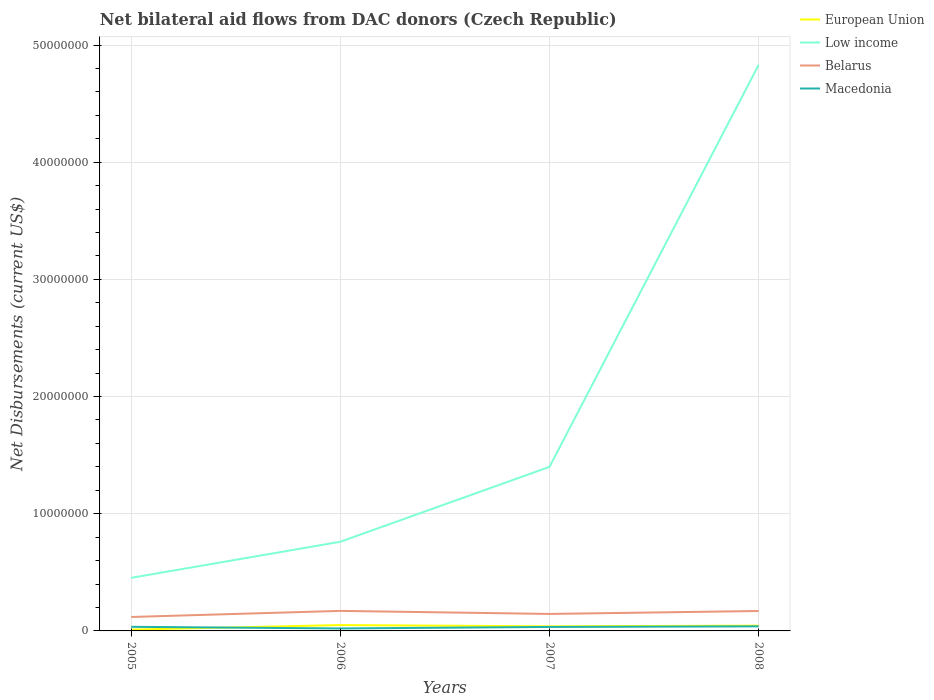Does the line corresponding to Macedonia intersect with the line corresponding to Belarus?
Offer a very short reply. No. What is the total net bilateral aid flows in European Union in the graph?
Offer a very short reply. -2.80e+05. What is the difference between the highest and the second highest net bilateral aid flows in Macedonia?
Provide a short and direct response. 1.80e+05. How many years are there in the graph?
Keep it short and to the point. 4. Does the graph contain grids?
Offer a very short reply. Yes. How many legend labels are there?
Offer a terse response. 4. How are the legend labels stacked?
Give a very brief answer. Vertical. What is the title of the graph?
Provide a short and direct response. Net bilateral aid flows from DAC donors (Czech Republic). Does "Sudan" appear as one of the legend labels in the graph?
Provide a short and direct response. No. What is the label or title of the X-axis?
Offer a very short reply. Years. What is the label or title of the Y-axis?
Offer a terse response. Net Disbursements (current US$). What is the Net Disbursements (current US$) in Low income in 2005?
Give a very brief answer. 4.53e+06. What is the Net Disbursements (current US$) in Belarus in 2005?
Your answer should be very brief. 1.19e+06. What is the Net Disbursements (current US$) in Macedonia in 2005?
Your response must be concise. 3.50e+05. What is the Net Disbursements (current US$) in European Union in 2006?
Your answer should be compact. 5.00e+05. What is the Net Disbursements (current US$) of Low income in 2006?
Offer a terse response. 7.61e+06. What is the Net Disbursements (current US$) in Belarus in 2006?
Your answer should be very brief. 1.71e+06. What is the Net Disbursements (current US$) of Macedonia in 2006?
Give a very brief answer. 2.10e+05. What is the Net Disbursements (current US$) of European Union in 2007?
Make the answer very short. 3.90e+05. What is the Net Disbursements (current US$) in Low income in 2007?
Give a very brief answer. 1.40e+07. What is the Net Disbursements (current US$) in Belarus in 2007?
Make the answer very short. 1.45e+06. What is the Net Disbursements (current US$) in Low income in 2008?
Give a very brief answer. 4.83e+07. What is the Net Disbursements (current US$) in Belarus in 2008?
Your answer should be very brief. 1.70e+06. What is the Net Disbursements (current US$) of Macedonia in 2008?
Keep it short and to the point. 3.90e+05. Across all years, what is the maximum Net Disbursements (current US$) in Low income?
Your response must be concise. 4.83e+07. Across all years, what is the maximum Net Disbursements (current US$) in Belarus?
Provide a short and direct response. 1.71e+06. Across all years, what is the maximum Net Disbursements (current US$) of Macedonia?
Keep it short and to the point. 3.90e+05. Across all years, what is the minimum Net Disbursements (current US$) in Low income?
Offer a very short reply. 4.53e+06. Across all years, what is the minimum Net Disbursements (current US$) of Belarus?
Provide a succinct answer. 1.19e+06. Across all years, what is the minimum Net Disbursements (current US$) of Macedonia?
Your answer should be compact. 2.10e+05. What is the total Net Disbursements (current US$) of European Union in the graph?
Ensure brevity in your answer.  1.45e+06. What is the total Net Disbursements (current US$) in Low income in the graph?
Your answer should be very brief. 7.44e+07. What is the total Net Disbursements (current US$) in Belarus in the graph?
Provide a short and direct response. 6.05e+06. What is the total Net Disbursements (current US$) in Macedonia in the graph?
Your answer should be very brief. 1.29e+06. What is the difference between the Net Disbursements (current US$) of European Union in 2005 and that in 2006?
Your answer should be very brief. -3.90e+05. What is the difference between the Net Disbursements (current US$) of Low income in 2005 and that in 2006?
Keep it short and to the point. -3.08e+06. What is the difference between the Net Disbursements (current US$) of Belarus in 2005 and that in 2006?
Provide a succinct answer. -5.20e+05. What is the difference between the Net Disbursements (current US$) in European Union in 2005 and that in 2007?
Your answer should be very brief. -2.80e+05. What is the difference between the Net Disbursements (current US$) of Low income in 2005 and that in 2007?
Offer a terse response. -9.47e+06. What is the difference between the Net Disbursements (current US$) of Belarus in 2005 and that in 2007?
Make the answer very short. -2.60e+05. What is the difference between the Net Disbursements (current US$) of European Union in 2005 and that in 2008?
Make the answer very short. -3.40e+05. What is the difference between the Net Disbursements (current US$) in Low income in 2005 and that in 2008?
Ensure brevity in your answer.  -4.38e+07. What is the difference between the Net Disbursements (current US$) in Belarus in 2005 and that in 2008?
Your answer should be compact. -5.10e+05. What is the difference between the Net Disbursements (current US$) of Macedonia in 2005 and that in 2008?
Offer a very short reply. -4.00e+04. What is the difference between the Net Disbursements (current US$) in European Union in 2006 and that in 2007?
Give a very brief answer. 1.10e+05. What is the difference between the Net Disbursements (current US$) in Low income in 2006 and that in 2007?
Your response must be concise. -6.39e+06. What is the difference between the Net Disbursements (current US$) of European Union in 2006 and that in 2008?
Keep it short and to the point. 5.00e+04. What is the difference between the Net Disbursements (current US$) in Low income in 2006 and that in 2008?
Your answer should be very brief. -4.07e+07. What is the difference between the Net Disbursements (current US$) in European Union in 2007 and that in 2008?
Provide a short and direct response. -6.00e+04. What is the difference between the Net Disbursements (current US$) in Low income in 2007 and that in 2008?
Offer a terse response. -3.43e+07. What is the difference between the Net Disbursements (current US$) in Belarus in 2007 and that in 2008?
Give a very brief answer. -2.50e+05. What is the difference between the Net Disbursements (current US$) of Macedonia in 2007 and that in 2008?
Offer a very short reply. -5.00e+04. What is the difference between the Net Disbursements (current US$) of European Union in 2005 and the Net Disbursements (current US$) of Low income in 2006?
Keep it short and to the point. -7.50e+06. What is the difference between the Net Disbursements (current US$) in European Union in 2005 and the Net Disbursements (current US$) in Belarus in 2006?
Your answer should be very brief. -1.60e+06. What is the difference between the Net Disbursements (current US$) in Low income in 2005 and the Net Disbursements (current US$) in Belarus in 2006?
Offer a terse response. 2.82e+06. What is the difference between the Net Disbursements (current US$) in Low income in 2005 and the Net Disbursements (current US$) in Macedonia in 2006?
Keep it short and to the point. 4.32e+06. What is the difference between the Net Disbursements (current US$) in Belarus in 2005 and the Net Disbursements (current US$) in Macedonia in 2006?
Ensure brevity in your answer.  9.80e+05. What is the difference between the Net Disbursements (current US$) of European Union in 2005 and the Net Disbursements (current US$) of Low income in 2007?
Give a very brief answer. -1.39e+07. What is the difference between the Net Disbursements (current US$) in European Union in 2005 and the Net Disbursements (current US$) in Belarus in 2007?
Keep it short and to the point. -1.34e+06. What is the difference between the Net Disbursements (current US$) of Low income in 2005 and the Net Disbursements (current US$) of Belarus in 2007?
Your answer should be compact. 3.08e+06. What is the difference between the Net Disbursements (current US$) in Low income in 2005 and the Net Disbursements (current US$) in Macedonia in 2007?
Provide a succinct answer. 4.19e+06. What is the difference between the Net Disbursements (current US$) of Belarus in 2005 and the Net Disbursements (current US$) of Macedonia in 2007?
Keep it short and to the point. 8.50e+05. What is the difference between the Net Disbursements (current US$) in European Union in 2005 and the Net Disbursements (current US$) in Low income in 2008?
Provide a succinct answer. -4.82e+07. What is the difference between the Net Disbursements (current US$) in European Union in 2005 and the Net Disbursements (current US$) in Belarus in 2008?
Provide a short and direct response. -1.59e+06. What is the difference between the Net Disbursements (current US$) in European Union in 2005 and the Net Disbursements (current US$) in Macedonia in 2008?
Provide a succinct answer. -2.80e+05. What is the difference between the Net Disbursements (current US$) in Low income in 2005 and the Net Disbursements (current US$) in Belarus in 2008?
Offer a very short reply. 2.83e+06. What is the difference between the Net Disbursements (current US$) of Low income in 2005 and the Net Disbursements (current US$) of Macedonia in 2008?
Provide a succinct answer. 4.14e+06. What is the difference between the Net Disbursements (current US$) in Belarus in 2005 and the Net Disbursements (current US$) in Macedonia in 2008?
Offer a very short reply. 8.00e+05. What is the difference between the Net Disbursements (current US$) in European Union in 2006 and the Net Disbursements (current US$) in Low income in 2007?
Offer a terse response. -1.35e+07. What is the difference between the Net Disbursements (current US$) of European Union in 2006 and the Net Disbursements (current US$) of Belarus in 2007?
Your answer should be compact. -9.50e+05. What is the difference between the Net Disbursements (current US$) of Low income in 2006 and the Net Disbursements (current US$) of Belarus in 2007?
Your response must be concise. 6.16e+06. What is the difference between the Net Disbursements (current US$) of Low income in 2006 and the Net Disbursements (current US$) of Macedonia in 2007?
Provide a short and direct response. 7.27e+06. What is the difference between the Net Disbursements (current US$) of Belarus in 2006 and the Net Disbursements (current US$) of Macedonia in 2007?
Ensure brevity in your answer.  1.37e+06. What is the difference between the Net Disbursements (current US$) of European Union in 2006 and the Net Disbursements (current US$) of Low income in 2008?
Ensure brevity in your answer.  -4.78e+07. What is the difference between the Net Disbursements (current US$) in European Union in 2006 and the Net Disbursements (current US$) in Belarus in 2008?
Your answer should be compact. -1.20e+06. What is the difference between the Net Disbursements (current US$) of European Union in 2006 and the Net Disbursements (current US$) of Macedonia in 2008?
Offer a very short reply. 1.10e+05. What is the difference between the Net Disbursements (current US$) of Low income in 2006 and the Net Disbursements (current US$) of Belarus in 2008?
Offer a very short reply. 5.91e+06. What is the difference between the Net Disbursements (current US$) in Low income in 2006 and the Net Disbursements (current US$) in Macedonia in 2008?
Make the answer very short. 7.22e+06. What is the difference between the Net Disbursements (current US$) of Belarus in 2006 and the Net Disbursements (current US$) of Macedonia in 2008?
Your answer should be compact. 1.32e+06. What is the difference between the Net Disbursements (current US$) in European Union in 2007 and the Net Disbursements (current US$) in Low income in 2008?
Ensure brevity in your answer.  -4.79e+07. What is the difference between the Net Disbursements (current US$) in European Union in 2007 and the Net Disbursements (current US$) in Belarus in 2008?
Ensure brevity in your answer.  -1.31e+06. What is the difference between the Net Disbursements (current US$) of European Union in 2007 and the Net Disbursements (current US$) of Macedonia in 2008?
Your response must be concise. 0. What is the difference between the Net Disbursements (current US$) of Low income in 2007 and the Net Disbursements (current US$) of Belarus in 2008?
Offer a terse response. 1.23e+07. What is the difference between the Net Disbursements (current US$) in Low income in 2007 and the Net Disbursements (current US$) in Macedonia in 2008?
Ensure brevity in your answer.  1.36e+07. What is the difference between the Net Disbursements (current US$) of Belarus in 2007 and the Net Disbursements (current US$) of Macedonia in 2008?
Your response must be concise. 1.06e+06. What is the average Net Disbursements (current US$) of European Union per year?
Make the answer very short. 3.62e+05. What is the average Net Disbursements (current US$) of Low income per year?
Provide a succinct answer. 1.86e+07. What is the average Net Disbursements (current US$) in Belarus per year?
Provide a succinct answer. 1.51e+06. What is the average Net Disbursements (current US$) of Macedonia per year?
Make the answer very short. 3.22e+05. In the year 2005, what is the difference between the Net Disbursements (current US$) of European Union and Net Disbursements (current US$) of Low income?
Give a very brief answer. -4.42e+06. In the year 2005, what is the difference between the Net Disbursements (current US$) of European Union and Net Disbursements (current US$) of Belarus?
Your answer should be very brief. -1.08e+06. In the year 2005, what is the difference between the Net Disbursements (current US$) of Low income and Net Disbursements (current US$) of Belarus?
Make the answer very short. 3.34e+06. In the year 2005, what is the difference between the Net Disbursements (current US$) of Low income and Net Disbursements (current US$) of Macedonia?
Offer a very short reply. 4.18e+06. In the year 2005, what is the difference between the Net Disbursements (current US$) of Belarus and Net Disbursements (current US$) of Macedonia?
Ensure brevity in your answer.  8.40e+05. In the year 2006, what is the difference between the Net Disbursements (current US$) in European Union and Net Disbursements (current US$) in Low income?
Keep it short and to the point. -7.11e+06. In the year 2006, what is the difference between the Net Disbursements (current US$) in European Union and Net Disbursements (current US$) in Belarus?
Make the answer very short. -1.21e+06. In the year 2006, what is the difference between the Net Disbursements (current US$) in Low income and Net Disbursements (current US$) in Belarus?
Ensure brevity in your answer.  5.90e+06. In the year 2006, what is the difference between the Net Disbursements (current US$) in Low income and Net Disbursements (current US$) in Macedonia?
Your response must be concise. 7.40e+06. In the year 2006, what is the difference between the Net Disbursements (current US$) of Belarus and Net Disbursements (current US$) of Macedonia?
Keep it short and to the point. 1.50e+06. In the year 2007, what is the difference between the Net Disbursements (current US$) in European Union and Net Disbursements (current US$) in Low income?
Keep it short and to the point. -1.36e+07. In the year 2007, what is the difference between the Net Disbursements (current US$) in European Union and Net Disbursements (current US$) in Belarus?
Offer a very short reply. -1.06e+06. In the year 2007, what is the difference between the Net Disbursements (current US$) in Low income and Net Disbursements (current US$) in Belarus?
Provide a short and direct response. 1.26e+07. In the year 2007, what is the difference between the Net Disbursements (current US$) in Low income and Net Disbursements (current US$) in Macedonia?
Your answer should be compact. 1.37e+07. In the year 2007, what is the difference between the Net Disbursements (current US$) in Belarus and Net Disbursements (current US$) in Macedonia?
Provide a short and direct response. 1.11e+06. In the year 2008, what is the difference between the Net Disbursements (current US$) in European Union and Net Disbursements (current US$) in Low income?
Your answer should be very brief. -4.79e+07. In the year 2008, what is the difference between the Net Disbursements (current US$) of European Union and Net Disbursements (current US$) of Belarus?
Your answer should be compact. -1.25e+06. In the year 2008, what is the difference between the Net Disbursements (current US$) in European Union and Net Disbursements (current US$) in Macedonia?
Ensure brevity in your answer.  6.00e+04. In the year 2008, what is the difference between the Net Disbursements (current US$) in Low income and Net Disbursements (current US$) in Belarus?
Ensure brevity in your answer.  4.66e+07. In the year 2008, what is the difference between the Net Disbursements (current US$) in Low income and Net Disbursements (current US$) in Macedonia?
Provide a succinct answer. 4.79e+07. In the year 2008, what is the difference between the Net Disbursements (current US$) of Belarus and Net Disbursements (current US$) of Macedonia?
Your answer should be compact. 1.31e+06. What is the ratio of the Net Disbursements (current US$) of European Union in 2005 to that in 2006?
Your answer should be very brief. 0.22. What is the ratio of the Net Disbursements (current US$) in Low income in 2005 to that in 2006?
Your answer should be very brief. 0.6. What is the ratio of the Net Disbursements (current US$) of Belarus in 2005 to that in 2006?
Make the answer very short. 0.7. What is the ratio of the Net Disbursements (current US$) in European Union in 2005 to that in 2007?
Give a very brief answer. 0.28. What is the ratio of the Net Disbursements (current US$) in Low income in 2005 to that in 2007?
Make the answer very short. 0.32. What is the ratio of the Net Disbursements (current US$) in Belarus in 2005 to that in 2007?
Ensure brevity in your answer.  0.82. What is the ratio of the Net Disbursements (current US$) in Macedonia in 2005 to that in 2007?
Ensure brevity in your answer.  1.03. What is the ratio of the Net Disbursements (current US$) in European Union in 2005 to that in 2008?
Provide a short and direct response. 0.24. What is the ratio of the Net Disbursements (current US$) of Low income in 2005 to that in 2008?
Give a very brief answer. 0.09. What is the ratio of the Net Disbursements (current US$) in Macedonia in 2005 to that in 2008?
Offer a terse response. 0.9. What is the ratio of the Net Disbursements (current US$) of European Union in 2006 to that in 2007?
Offer a terse response. 1.28. What is the ratio of the Net Disbursements (current US$) of Low income in 2006 to that in 2007?
Your answer should be very brief. 0.54. What is the ratio of the Net Disbursements (current US$) in Belarus in 2006 to that in 2007?
Your answer should be very brief. 1.18. What is the ratio of the Net Disbursements (current US$) in Macedonia in 2006 to that in 2007?
Ensure brevity in your answer.  0.62. What is the ratio of the Net Disbursements (current US$) in European Union in 2006 to that in 2008?
Give a very brief answer. 1.11. What is the ratio of the Net Disbursements (current US$) in Low income in 2006 to that in 2008?
Offer a very short reply. 0.16. What is the ratio of the Net Disbursements (current US$) in Belarus in 2006 to that in 2008?
Provide a succinct answer. 1.01. What is the ratio of the Net Disbursements (current US$) in Macedonia in 2006 to that in 2008?
Offer a terse response. 0.54. What is the ratio of the Net Disbursements (current US$) in European Union in 2007 to that in 2008?
Your answer should be compact. 0.87. What is the ratio of the Net Disbursements (current US$) in Low income in 2007 to that in 2008?
Provide a short and direct response. 0.29. What is the ratio of the Net Disbursements (current US$) in Belarus in 2007 to that in 2008?
Your response must be concise. 0.85. What is the ratio of the Net Disbursements (current US$) in Macedonia in 2007 to that in 2008?
Ensure brevity in your answer.  0.87. What is the difference between the highest and the second highest Net Disbursements (current US$) in Low income?
Provide a short and direct response. 3.43e+07. What is the difference between the highest and the lowest Net Disbursements (current US$) of Low income?
Provide a succinct answer. 4.38e+07. What is the difference between the highest and the lowest Net Disbursements (current US$) of Belarus?
Your answer should be very brief. 5.20e+05. What is the difference between the highest and the lowest Net Disbursements (current US$) of Macedonia?
Give a very brief answer. 1.80e+05. 